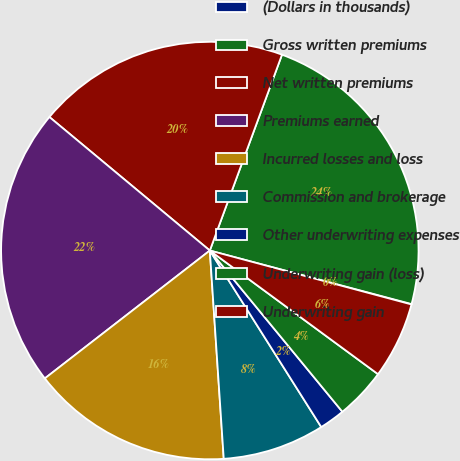<chart> <loc_0><loc_0><loc_500><loc_500><pie_chart><fcel>(Dollars in thousands)<fcel>Gross written premiums<fcel>Net written premiums<fcel>Premiums earned<fcel>Incurred losses and loss<fcel>Commission and brokerage<fcel>Other underwriting expenses<fcel>Underwriting gain (loss)<fcel>Underwriting gain<nl><fcel>0.03%<fcel>23.51%<fcel>19.57%<fcel>21.54%<fcel>15.57%<fcel>7.9%<fcel>1.99%<fcel>3.96%<fcel>5.93%<nl></chart> 